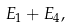Convert formula to latex. <formula><loc_0><loc_0><loc_500><loc_500>E _ { 1 } + E _ { 4 } ,</formula> 